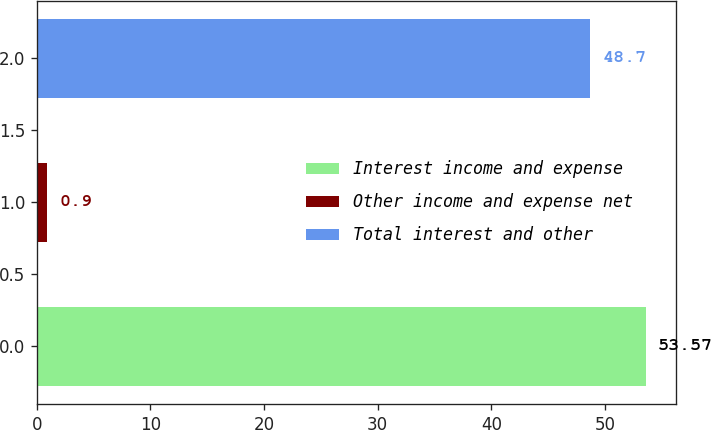Convert chart to OTSL. <chart><loc_0><loc_0><loc_500><loc_500><bar_chart><fcel>Interest income and expense<fcel>Other income and expense net<fcel>Total interest and other<nl><fcel>53.57<fcel>0.9<fcel>48.7<nl></chart> 